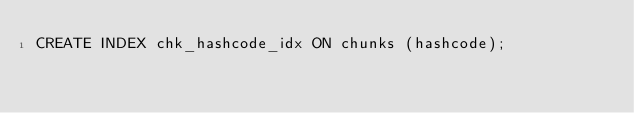Convert code to text. <code><loc_0><loc_0><loc_500><loc_500><_SQL_>CREATE INDEX chk_hashcode_idx ON chunks (hashcode);</code> 